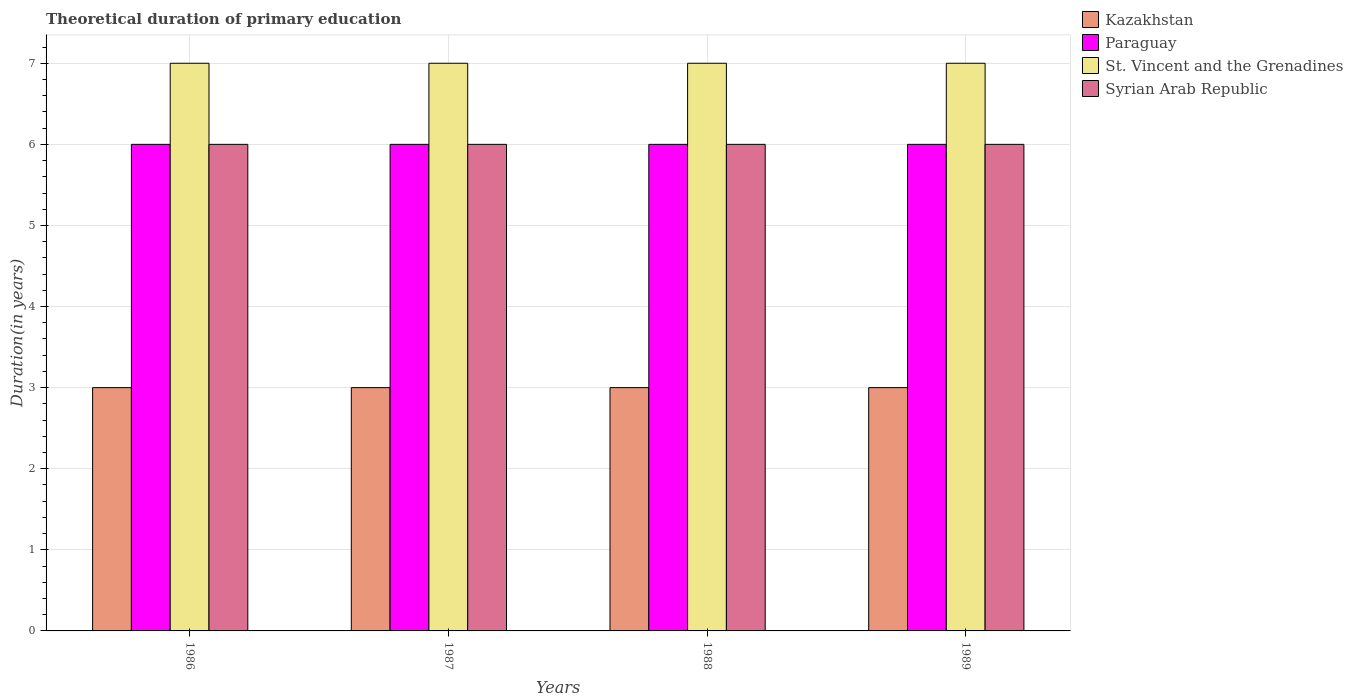How many bars are there on the 4th tick from the left?
Your answer should be very brief. 4. How many bars are there on the 2nd tick from the right?
Your answer should be very brief. 4. In how many cases, is the number of bars for a given year not equal to the number of legend labels?
Provide a short and direct response. 0. In which year was the total theoretical duration of primary education in St. Vincent and the Grenadines minimum?
Keep it short and to the point. 1986. What is the total total theoretical duration of primary education in Syrian Arab Republic in the graph?
Offer a terse response. 24. What is the difference between the total theoretical duration of primary education in St. Vincent and the Grenadines in 1988 and that in 1989?
Offer a very short reply. 0. What is the difference between the total theoretical duration of primary education in Paraguay in 1988 and the total theoretical duration of primary education in St. Vincent and the Grenadines in 1986?
Give a very brief answer. -1. In the year 1987, what is the difference between the total theoretical duration of primary education in St. Vincent and the Grenadines and total theoretical duration of primary education in Syrian Arab Republic?
Make the answer very short. 1. Is the total theoretical duration of primary education in Syrian Arab Republic in 1987 less than that in 1989?
Your answer should be compact. No. What is the difference between the highest and the second highest total theoretical duration of primary education in Kazakhstan?
Provide a short and direct response. 0. Is it the case that in every year, the sum of the total theoretical duration of primary education in Syrian Arab Republic and total theoretical duration of primary education in Paraguay is greater than the sum of total theoretical duration of primary education in St. Vincent and the Grenadines and total theoretical duration of primary education in Kazakhstan?
Offer a terse response. No. What does the 4th bar from the left in 1987 represents?
Provide a succinct answer. Syrian Arab Republic. What does the 2nd bar from the right in 1989 represents?
Offer a very short reply. St. Vincent and the Grenadines. How many years are there in the graph?
Provide a succinct answer. 4. Does the graph contain any zero values?
Provide a succinct answer. No. Does the graph contain grids?
Provide a short and direct response. Yes. Where does the legend appear in the graph?
Your answer should be very brief. Top right. How many legend labels are there?
Make the answer very short. 4. What is the title of the graph?
Provide a short and direct response. Theoretical duration of primary education. What is the label or title of the Y-axis?
Your answer should be very brief. Duration(in years). What is the Duration(in years) of St. Vincent and the Grenadines in 1986?
Your answer should be compact. 7. What is the Duration(in years) in Syrian Arab Republic in 1986?
Make the answer very short. 6. What is the Duration(in years) in Kazakhstan in 1987?
Ensure brevity in your answer.  3. What is the Duration(in years) in Syrian Arab Republic in 1987?
Your answer should be compact. 6. What is the Duration(in years) in Kazakhstan in 1988?
Offer a very short reply. 3. What is the Duration(in years) in Syrian Arab Republic in 1988?
Provide a succinct answer. 6. What is the Duration(in years) in Syrian Arab Republic in 1989?
Keep it short and to the point. 6. Across all years, what is the maximum Duration(in years) in St. Vincent and the Grenadines?
Provide a succinct answer. 7. Across all years, what is the minimum Duration(in years) of Kazakhstan?
Your answer should be very brief. 3. Across all years, what is the minimum Duration(in years) of Syrian Arab Republic?
Make the answer very short. 6. What is the total Duration(in years) in Kazakhstan in the graph?
Offer a terse response. 12. What is the total Duration(in years) of St. Vincent and the Grenadines in the graph?
Your response must be concise. 28. What is the total Duration(in years) of Syrian Arab Republic in the graph?
Provide a succinct answer. 24. What is the difference between the Duration(in years) in Paraguay in 1986 and that in 1987?
Provide a succinct answer. 0. What is the difference between the Duration(in years) in Syrian Arab Republic in 1986 and that in 1987?
Offer a terse response. 0. What is the difference between the Duration(in years) in Paraguay in 1986 and that in 1988?
Make the answer very short. 0. What is the difference between the Duration(in years) of St. Vincent and the Grenadines in 1986 and that in 1988?
Provide a short and direct response. 0. What is the difference between the Duration(in years) in Paraguay in 1987 and that in 1988?
Your answer should be very brief. 0. What is the difference between the Duration(in years) in St. Vincent and the Grenadines in 1987 and that in 1988?
Ensure brevity in your answer.  0. What is the difference between the Duration(in years) in Kazakhstan in 1987 and that in 1989?
Provide a succinct answer. 0. What is the difference between the Duration(in years) of Paraguay in 1987 and that in 1989?
Give a very brief answer. 0. What is the difference between the Duration(in years) in St. Vincent and the Grenadines in 1987 and that in 1989?
Make the answer very short. 0. What is the difference between the Duration(in years) in Paraguay in 1988 and that in 1989?
Offer a very short reply. 0. What is the difference between the Duration(in years) of St. Vincent and the Grenadines in 1988 and that in 1989?
Keep it short and to the point. 0. What is the difference between the Duration(in years) of Syrian Arab Republic in 1988 and that in 1989?
Give a very brief answer. 0. What is the difference between the Duration(in years) of Kazakhstan in 1986 and the Duration(in years) of Paraguay in 1987?
Give a very brief answer. -3. What is the difference between the Duration(in years) in Kazakhstan in 1986 and the Duration(in years) in Syrian Arab Republic in 1987?
Give a very brief answer. -3. What is the difference between the Duration(in years) in Kazakhstan in 1986 and the Duration(in years) in Syrian Arab Republic in 1988?
Your answer should be compact. -3. What is the difference between the Duration(in years) of Paraguay in 1986 and the Duration(in years) of St. Vincent and the Grenadines in 1988?
Offer a very short reply. -1. What is the difference between the Duration(in years) of Paraguay in 1986 and the Duration(in years) of Syrian Arab Republic in 1988?
Offer a terse response. 0. What is the difference between the Duration(in years) of Kazakhstan in 1986 and the Duration(in years) of Paraguay in 1989?
Offer a terse response. -3. What is the difference between the Duration(in years) of Kazakhstan in 1986 and the Duration(in years) of St. Vincent and the Grenadines in 1989?
Provide a short and direct response. -4. What is the difference between the Duration(in years) of Kazakhstan in 1986 and the Duration(in years) of Syrian Arab Republic in 1989?
Offer a terse response. -3. What is the difference between the Duration(in years) in Paraguay in 1986 and the Duration(in years) in Syrian Arab Republic in 1989?
Give a very brief answer. 0. What is the difference between the Duration(in years) of St. Vincent and the Grenadines in 1986 and the Duration(in years) of Syrian Arab Republic in 1989?
Your answer should be very brief. 1. What is the difference between the Duration(in years) of Kazakhstan in 1987 and the Duration(in years) of St. Vincent and the Grenadines in 1988?
Keep it short and to the point. -4. What is the difference between the Duration(in years) in Kazakhstan in 1987 and the Duration(in years) in Syrian Arab Republic in 1988?
Provide a succinct answer. -3. What is the difference between the Duration(in years) of Paraguay in 1987 and the Duration(in years) of St. Vincent and the Grenadines in 1988?
Your answer should be very brief. -1. What is the difference between the Duration(in years) of St. Vincent and the Grenadines in 1987 and the Duration(in years) of Syrian Arab Republic in 1988?
Offer a terse response. 1. What is the difference between the Duration(in years) of Kazakhstan in 1987 and the Duration(in years) of St. Vincent and the Grenadines in 1989?
Make the answer very short. -4. What is the difference between the Duration(in years) of Kazakhstan in 1987 and the Duration(in years) of Syrian Arab Republic in 1989?
Give a very brief answer. -3. What is the difference between the Duration(in years) of Paraguay in 1987 and the Duration(in years) of St. Vincent and the Grenadines in 1989?
Your answer should be very brief. -1. What is the difference between the Duration(in years) of Paraguay in 1987 and the Duration(in years) of Syrian Arab Republic in 1989?
Give a very brief answer. 0. What is the difference between the Duration(in years) in St. Vincent and the Grenadines in 1987 and the Duration(in years) in Syrian Arab Republic in 1989?
Provide a succinct answer. 1. What is the difference between the Duration(in years) of Kazakhstan in 1988 and the Duration(in years) of Paraguay in 1989?
Offer a terse response. -3. What is the difference between the Duration(in years) of Paraguay in 1988 and the Duration(in years) of St. Vincent and the Grenadines in 1989?
Ensure brevity in your answer.  -1. What is the average Duration(in years) in Kazakhstan per year?
Give a very brief answer. 3. What is the average Duration(in years) of Paraguay per year?
Your response must be concise. 6. What is the average Duration(in years) of St. Vincent and the Grenadines per year?
Offer a very short reply. 7. What is the average Duration(in years) of Syrian Arab Republic per year?
Your answer should be very brief. 6. In the year 1986, what is the difference between the Duration(in years) in Kazakhstan and Duration(in years) in Paraguay?
Your answer should be very brief. -3. In the year 1986, what is the difference between the Duration(in years) in Kazakhstan and Duration(in years) in Syrian Arab Republic?
Offer a terse response. -3. In the year 1986, what is the difference between the Duration(in years) in Paraguay and Duration(in years) in St. Vincent and the Grenadines?
Give a very brief answer. -1. In the year 1986, what is the difference between the Duration(in years) of Paraguay and Duration(in years) of Syrian Arab Republic?
Your response must be concise. 0. In the year 1987, what is the difference between the Duration(in years) of St. Vincent and the Grenadines and Duration(in years) of Syrian Arab Republic?
Your answer should be compact. 1. In the year 1988, what is the difference between the Duration(in years) in Kazakhstan and Duration(in years) in Syrian Arab Republic?
Your response must be concise. -3. In the year 1988, what is the difference between the Duration(in years) in Paraguay and Duration(in years) in St. Vincent and the Grenadines?
Offer a very short reply. -1. In the year 1988, what is the difference between the Duration(in years) of St. Vincent and the Grenadines and Duration(in years) of Syrian Arab Republic?
Offer a very short reply. 1. In the year 1989, what is the difference between the Duration(in years) of Kazakhstan and Duration(in years) of Paraguay?
Offer a terse response. -3. In the year 1989, what is the difference between the Duration(in years) of Kazakhstan and Duration(in years) of St. Vincent and the Grenadines?
Your response must be concise. -4. In the year 1989, what is the difference between the Duration(in years) in Paraguay and Duration(in years) in Syrian Arab Republic?
Provide a succinct answer. 0. What is the ratio of the Duration(in years) of St. Vincent and the Grenadines in 1986 to that in 1987?
Offer a very short reply. 1. What is the ratio of the Duration(in years) in Syrian Arab Republic in 1986 to that in 1987?
Provide a short and direct response. 1. What is the ratio of the Duration(in years) in Kazakhstan in 1986 to that in 1988?
Provide a short and direct response. 1. What is the ratio of the Duration(in years) in Paraguay in 1986 to that in 1988?
Give a very brief answer. 1. What is the ratio of the Duration(in years) in St. Vincent and the Grenadines in 1986 to that in 1988?
Provide a succinct answer. 1. What is the ratio of the Duration(in years) in Kazakhstan in 1986 to that in 1989?
Provide a succinct answer. 1. What is the ratio of the Duration(in years) of Paraguay in 1986 to that in 1989?
Your answer should be very brief. 1. What is the ratio of the Duration(in years) of St. Vincent and the Grenadines in 1986 to that in 1989?
Give a very brief answer. 1. What is the ratio of the Duration(in years) in Kazakhstan in 1987 to that in 1988?
Your response must be concise. 1. What is the ratio of the Duration(in years) in St. Vincent and the Grenadines in 1987 to that in 1988?
Keep it short and to the point. 1. What is the ratio of the Duration(in years) of Syrian Arab Republic in 1987 to that in 1988?
Keep it short and to the point. 1. What is the ratio of the Duration(in years) of Kazakhstan in 1987 to that in 1989?
Give a very brief answer. 1. What is the ratio of the Duration(in years) of Paraguay in 1987 to that in 1989?
Make the answer very short. 1. What is the ratio of the Duration(in years) in St. Vincent and the Grenadines in 1987 to that in 1989?
Make the answer very short. 1. What is the ratio of the Duration(in years) of Syrian Arab Republic in 1987 to that in 1989?
Offer a terse response. 1. What is the ratio of the Duration(in years) of Syrian Arab Republic in 1988 to that in 1989?
Give a very brief answer. 1. What is the difference between the highest and the second highest Duration(in years) of St. Vincent and the Grenadines?
Make the answer very short. 0. What is the difference between the highest and the lowest Duration(in years) of Paraguay?
Make the answer very short. 0. 